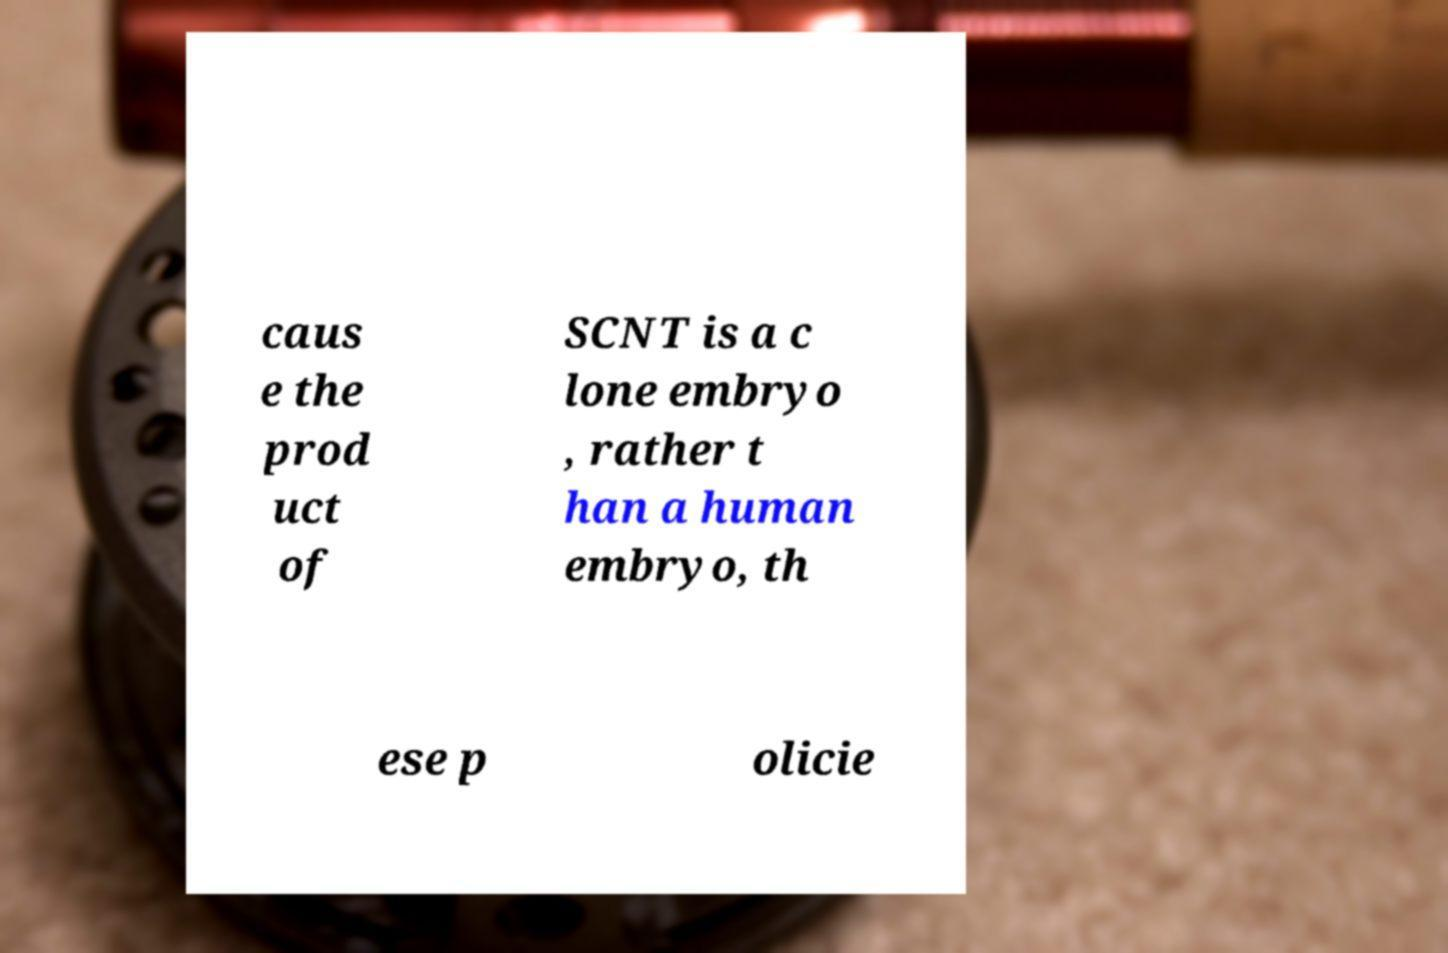Can you accurately transcribe the text from the provided image for me? caus e the prod uct of SCNT is a c lone embryo , rather t han a human embryo, th ese p olicie 